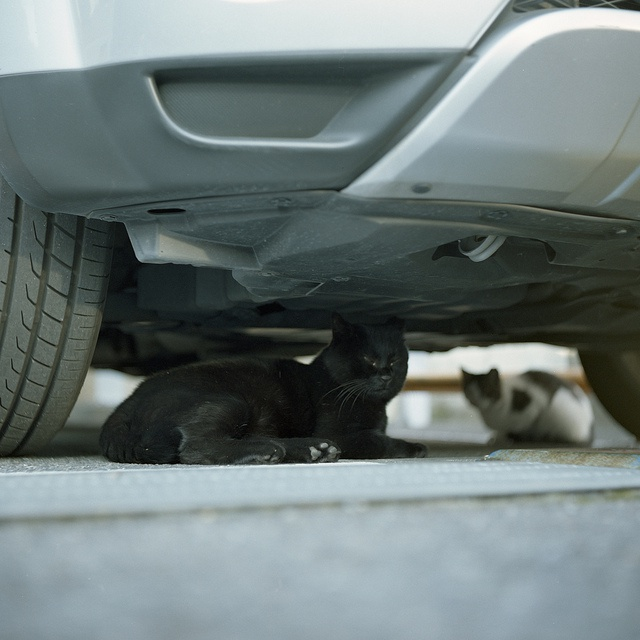Describe the objects in this image and their specific colors. I can see car in lightblue, gray, black, lightgray, and darkgray tones, cat in lightblue, black, gray, darkgray, and lightgray tones, and cat in lightblue, black, gray, and darkgray tones in this image. 